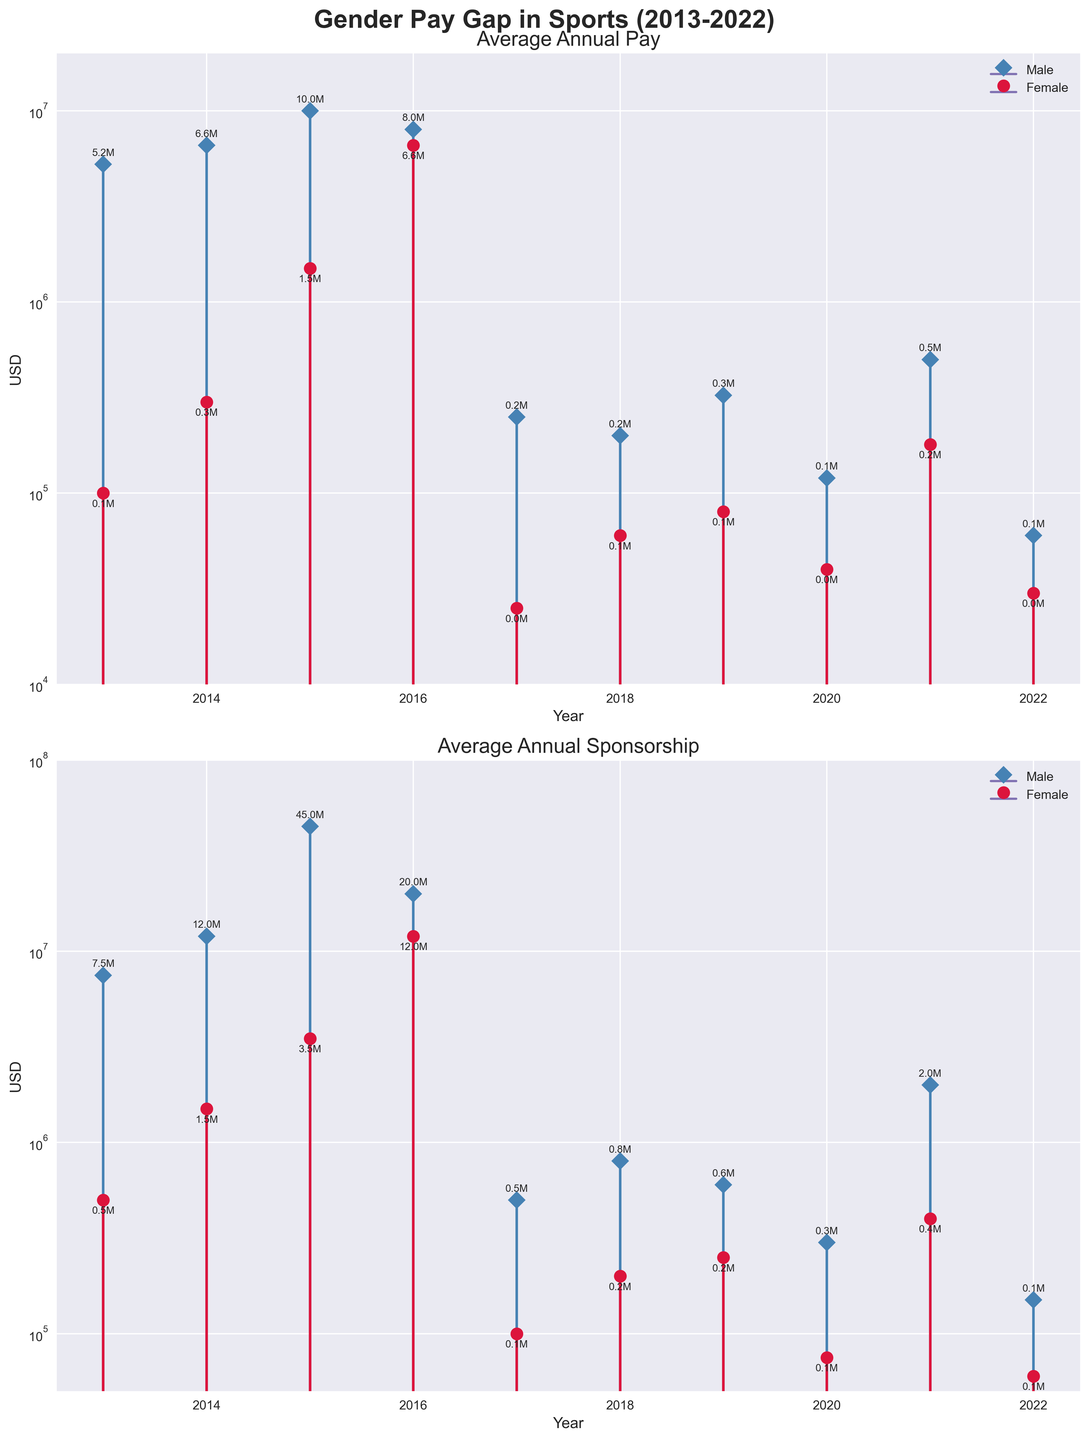What is the main title of the figure? The main title is usually found at the top of the figure, summarizing what the plot is about. In this case, it states "Gender Pay Gap in Sports (2013-2022)".
Answer: Gender Pay Gap in Sports (2013-2022) Which years show data for both 'Male' and 'Female' in the plot? By observing the x-axis, you can see that data points are plotted from 2013 to 2022 for both 'Male' and 'Female' labels.
Answer: 2013 to 2022 How does the average annual pay for 'Male' Basketball players in 2013 compare to 'Female' Basketball players in the same year? Locate the data points for Basketball in 2013. The male's pay is approximately $5,250,000 and the female's pay is $100,000.
Answer: Male pay is much higher than female pay in 2013 In which year is the sponsorship amount highest for both 'Male' and 'Female' athletes, and what sport does it correspond to? Observe both subplots for the highest markers and stem lines. In 2015, male golfers had the highest sponsorship at $45,000,000 and female golfers at $3,500,000.
Answer: 2015, Golf What is the trend of average annual sponsorship for male Tennis players from 2016 to 2017? The subplot for average annual sponsorship should be observed from 2016 to 2017 to see if the markers go up or down. For male Tennis players, the sponsorship decreases from $20,000,000 to an unspecified amount.
Answer: Decreasing Compare the pay gap: How did the difference in average annual pay between male and female athletes change from 2013 to 2022? Calculate the difference in the first year (2013) and the last year (2022). In 2013: $5,150,000. In 2022: $30,000. The gap significantly decreased.
Answer: Decreased significantly What is the range of years for which this data set provides information on 'Average Annual Sponsorship'? Identify the x-axis range for the bottom subplot related to average annual sponsorship data, ending from 2013 to 2022.
Answer: 2013 to 2022 In which sport and year do female athletes have the highest average annual pay, and what is the amount? Identify the highest point in the female athlete pay subplot. In 2016, female Tennis players have the highest pay of $6,600,000.
Answer: 2016, Tennis, $6,600,000 